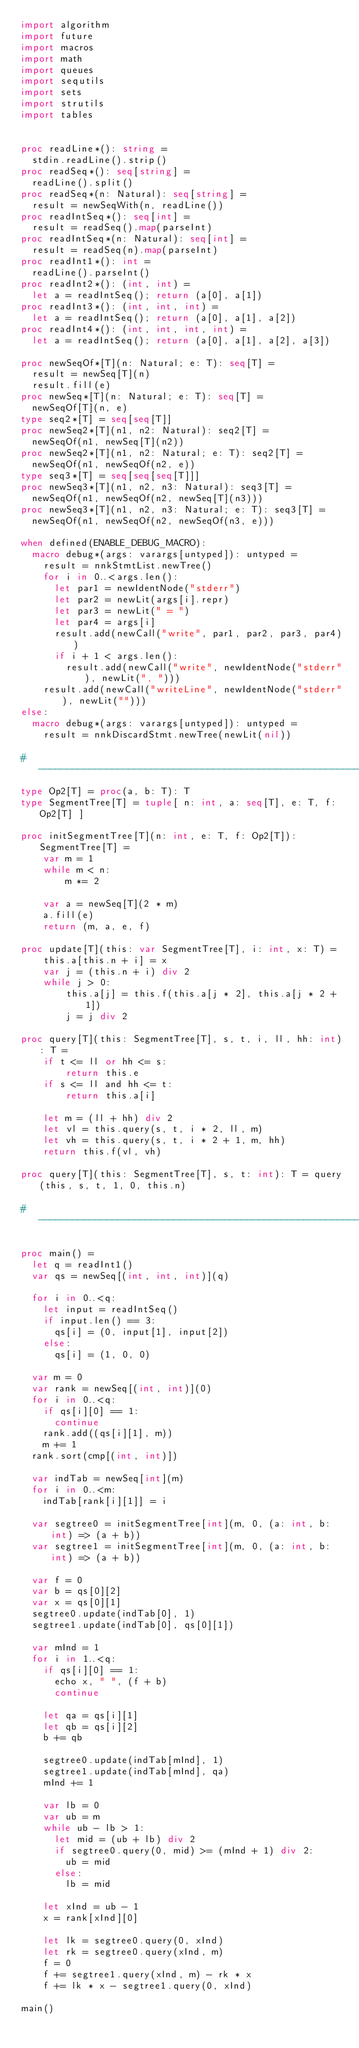Convert code to text. <code><loc_0><loc_0><loc_500><loc_500><_Nim_>import algorithm
import future
import macros
import math
import queues
import sequtils
import sets
import strutils
import tables


proc readLine*(): string =
  stdin.readLine().strip()
proc readSeq*(): seq[string] =
  readLine().split()
proc readSeq*(n: Natural): seq[string] =
  result = newSeqWith(n, readLine())
proc readIntSeq*(): seq[int] =
  result = readSeq().map(parseInt)
proc readIntSeq*(n: Natural): seq[int] =
  result = readSeq(n).map(parseInt)
proc readInt1*(): int =
  readLine().parseInt()
proc readInt2*(): (int, int) =
  let a = readIntSeq(); return (a[0], a[1])
proc readInt3*(): (int, int, int) =
  let a = readIntSeq(); return (a[0], a[1], a[2])
proc readInt4*(): (int, int, int, int) =
  let a = readIntSeq(); return (a[0], a[1], a[2], a[3])

proc newSeqOf*[T](n: Natural; e: T): seq[T] =
  result = newSeq[T](n)
  result.fill(e)
proc newSeq*[T](n: Natural; e: T): seq[T] =
  newSeqOf[T](n, e)
type seq2*[T] = seq[seq[T]]
proc newSeq2*[T](n1, n2: Natural): seq2[T] =
  newSeqOf(n1, newSeq[T](n2))
proc newSeq2*[T](n1, n2: Natural; e: T): seq2[T] =
  newSeqOf(n1, newSeqOf(n2, e))
type seq3*[T] = seq[seq[seq[T]]]
proc newSeq3*[T](n1, n2, n3: Natural): seq3[T] =
  newSeqOf(n1, newSeqOf(n2, newSeq[T](n3)))
proc newSeq3*[T](n1, n2, n3: Natural; e: T): seq3[T] =
  newSeqOf(n1, newSeqOf(n2, newSeqOf(n3, e)))

when defined(ENABLE_DEBUG_MACRO):
  macro debug*(args: varargs[untyped]): untyped =
    result = nnkStmtList.newTree()
    for i in 0..<args.len():
      let par1 = newIdentNode("stderr")
      let par2 = newLit(args[i].repr)
      let par3 = newLit(" = ")
      let par4 = args[i]
      result.add(newCall("write", par1, par2, par3, par4))
      if i + 1 < args.len():
        result.add(newCall("write", newIdentNode("stderr"), newLit(", ")))
    result.add(newCall("writeLine", newIdentNode("stderr"), newLit("")))
else:
  macro debug*(args: varargs[untyped]): untyped =
    result = nnkDiscardStmt.newTree(newLit(nil))

#------------------------------------------------------------------------------#
type Op2[T] = proc(a, b: T): T
type SegmentTree[T] = tuple[ n: int, a: seq[T], e: T, f: Op2[T] ]

proc initSegmentTree[T](n: int, e: T, f: Op2[T]): SegmentTree[T] =
    var m = 1
    while m < n:
        m *= 2

    var a = newSeq[T](2 * m)
    a.fill(e)
    return (m, a, e, f)

proc update[T](this: var SegmentTree[T], i: int, x: T) =
    this.a[this.n + i] = x
    var j = (this.n + i) div 2
    while j > 0:
        this.a[j] = this.f(this.a[j * 2], this.a[j * 2 + 1])
        j = j div 2

proc query[T](this: SegmentTree[T], s, t, i, ll, hh: int): T =
    if t <= ll or hh <= s:
        return this.e
    if s <= ll and hh <= t:
        return this.a[i]

    let m = (ll + hh) div 2
    let vl = this.query(s, t, i * 2, ll, m)
    let vh = this.query(s, t, i * 2 + 1, m, hh)
    return this.f(vl, vh)

proc query[T](this: SegmentTree[T], s, t: int): T = query(this, s, t, 1, 0, this.n)

#------------------------------------------------------------------------------#

proc main() =
  let q = readInt1()
  var qs = newSeq[(int, int, int)](q)

  for i in 0..<q:
    let input = readIntSeq()
    if input.len() == 3:
      qs[i] = (0, input[1], input[2])
    else:
      qs[i] = (1, 0, 0)

  var m = 0
  var rank = newSeq[(int, int)](0)
  for i in 0..<q:
    if qs[i][0] == 1:
      continue
    rank.add((qs[i][1], m))
    m += 1
  rank.sort(cmp[(int, int)])

  var indTab = newSeq[int](m)
  for i in 0..<m:
    indTab[rank[i][1]] = i

  var segtree0 = initSegmentTree[int](m, 0, (a: int, b: int) => (a + b))
  var segtree1 = initSegmentTree[int](m, 0, (a: int, b: int) => (a + b))

  var f = 0
  var b = qs[0][2]
  var x = qs[0][1]
  segtree0.update(indTab[0], 1)
  segtree1.update(indTab[0], qs[0][1])

  var mInd = 1
  for i in 1..<q:
    if qs[i][0] == 1:
      echo x, " ", (f + b)
      continue

    let qa = qs[i][1]
    let qb = qs[i][2]
    b += qb

    segtree0.update(indTab[mInd], 1)
    segtree1.update(indTab[mInd], qa)
    mInd += 1

    var lb = 0
    var ub = m
    while ub - lb > 1:
      let mid = (ub + lb) div 2
      if segtree0.query(0, mid) >= (mInd + 1) div 2:
        ub = mid
      else:
        lb = mid

    let xInd = ub - 1
    x = rank[xInd][0]

    let lk = segtree0.query(0, xInd)
    let rk = segtree0.query(xInd, m)
    f = 0
    f += segtree1.query(xInd, m) - rk * x
    f += lk * x - segtree1.query(0, xInd)

main()
</code> 